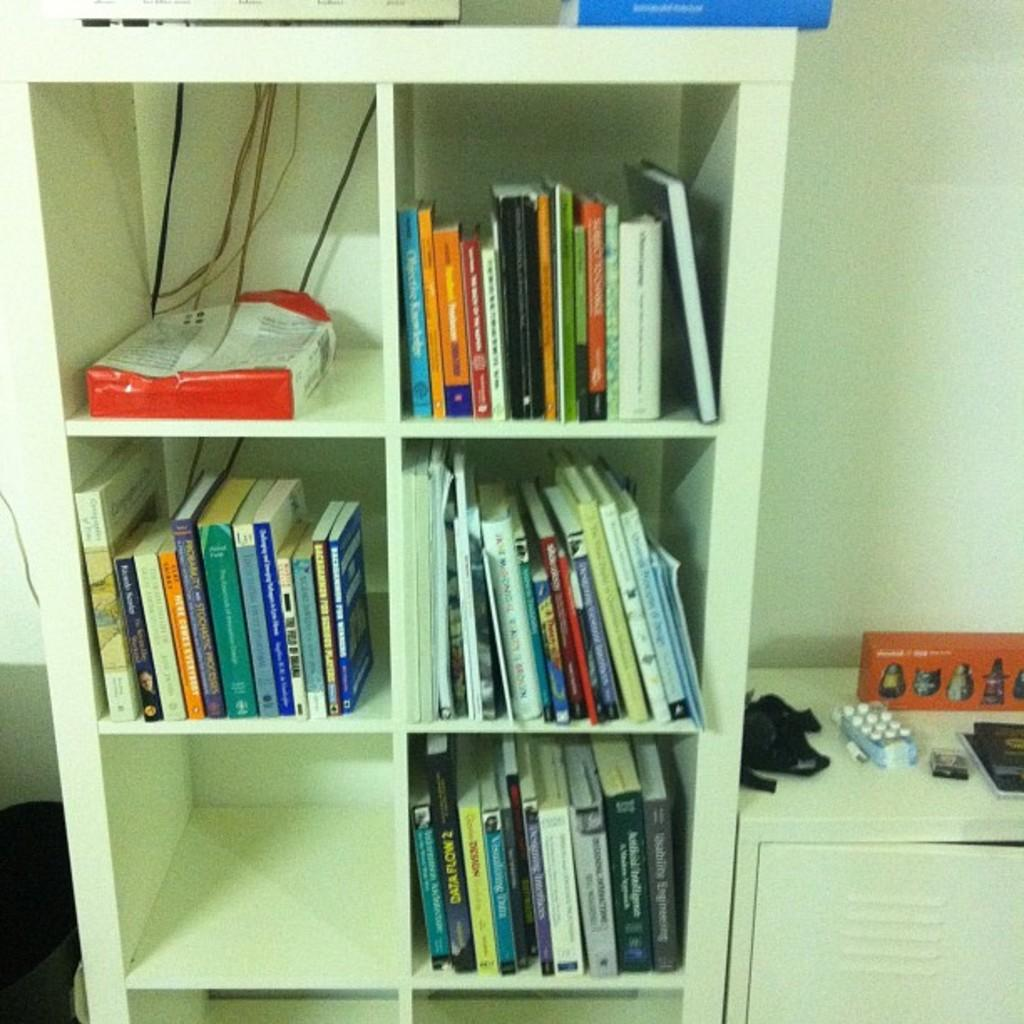What type of furniture is in the image? There is a cupboard in the image. What is on the cupboard? The cupboard has books on it. Is there any additional feature on the cupboard? Yes, there is a wire on the cupboard. What other piece of furniture is near the cupboard? There is a table beside the cupboard. What can be found on the table? There are objects on the table. How many boys are sitting on the table in the image? There are no boys present in the image. What color is the orange on the table in the image? There is no orange present in the image. 